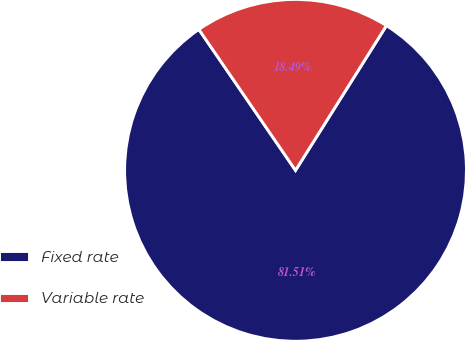Convert chart to OTSL. <chart><loc_0><loc_0><loc_500><loc_500><pie_chart><fcel>Fixed rate<fcel>Variable rate<nl><fcel>81.51%<fcel>18.49%<nl></chart> 